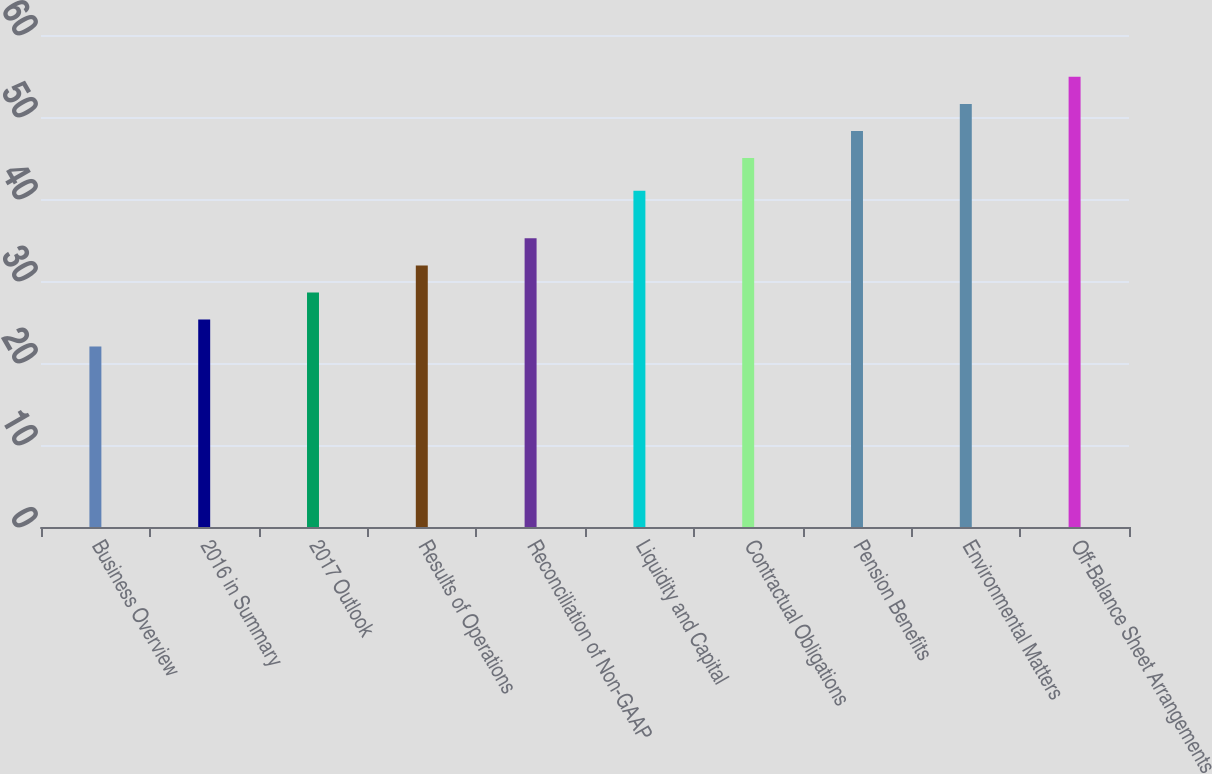Convert chart. <chart><loc_0><loc_0><loc_500><loc_500><bar_chart><fcel>Business Overview<fcel>2016 in Summary<fcel>2017 Outlook<fcel>Results of Operations<fcel>Reconciliation of Non-GAAP<fcel>Liquidity and Capital<fcel>Contractual Obligations<fcel>Pension Benefits<fcel>Environmental Matters<fcel>Off-Balance Sheet Arrangements<nl><fcel>22<fcel>25.3<fcel>28.6<fcel>31.9<fcel>35.2<fcel>41<fcel>45<fcel>48.3<fcel>51.6<fcel>54.9<nl></chart> 